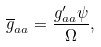<formula> <loc_0><loc_0><loc_500><loc_500>\overline { g } _ { a a } = \frac { g ^ { \prime } _ { a a } \psi } { \Omega } ,</formula> 